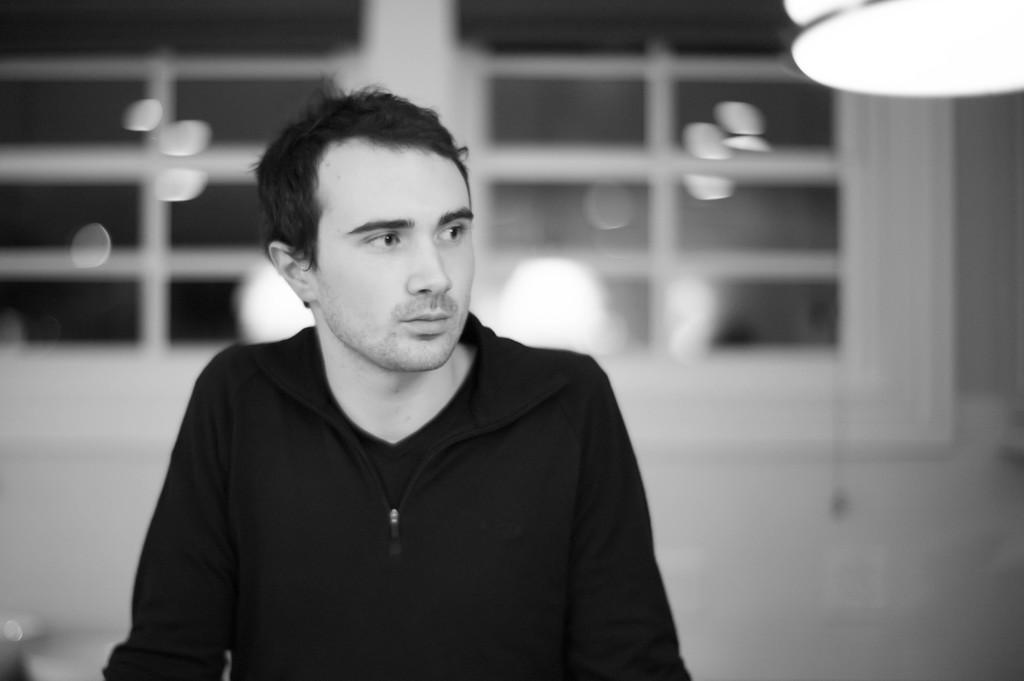Who or what is present in the image? There is a person in the image. What direction is the person looking in? The person is looking to the right side of the image. What can be seen in the background of the image? There is a wall and windows in the background of the image. Can you tell me how many baby worms are crawling on the person's shoulder in the image? There are no baby worms present in the image; the person is the only subject visible. 